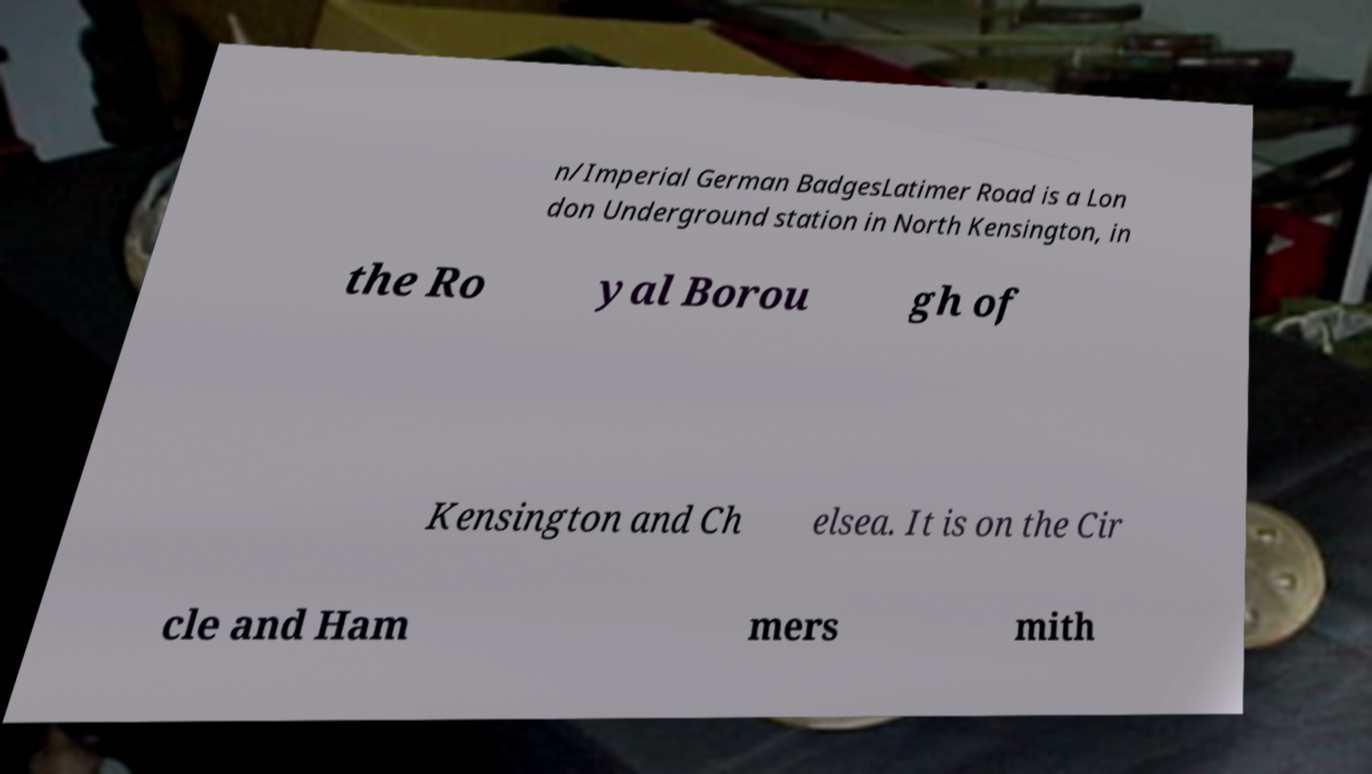Could you assist in decoding the text presented in this image and type it out clearly? n/Imperial German BadgesLatimer Road is a Lon don Underground station in North Kensington, in the Ro yal Borou gh of Kensington and Ch elsea. It is on the Cir cle and Ham mers mith 